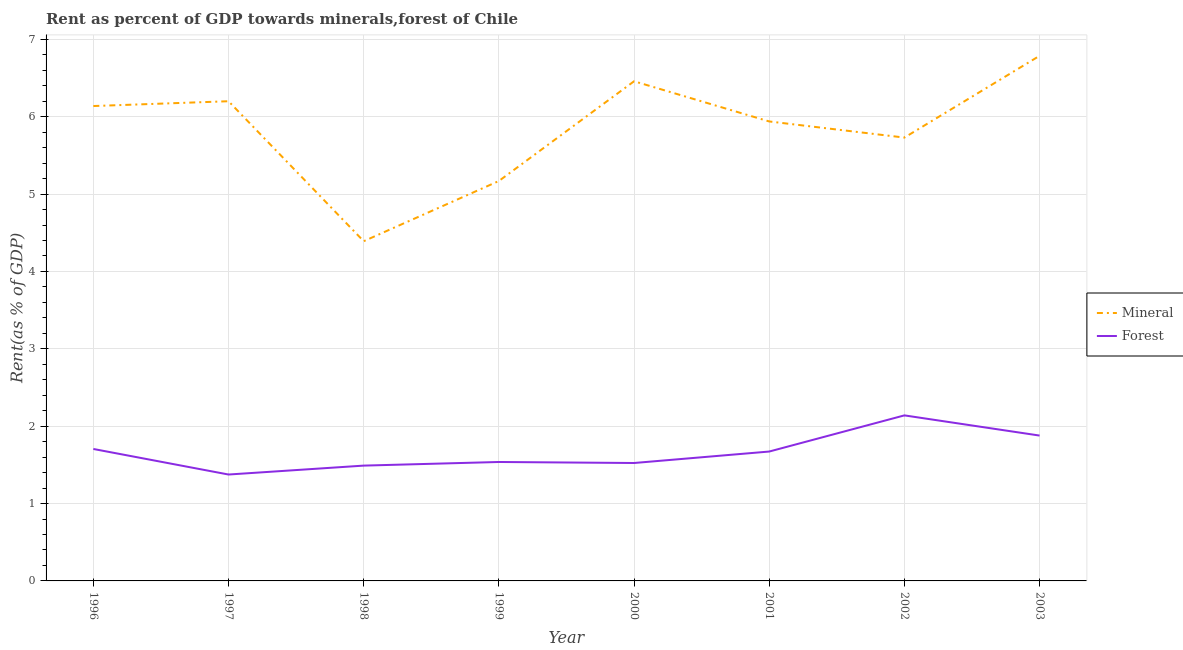Does the line corresponding to mineral rent intersect with the line corresponding to forest rent?
Provide a short and direct response. No. Is the number of lines equal to the number of legend labels?
Provide a succinct answer. Yes. What is the mineral rent in 1999?
Your answer should be compact. 5.17. Across all years, what is the maximum mineral rent?
Provide a succinct answer. 6.79. Across all years, what is the minimum mineral rent?
Keep it short and to the point. 4.39. In which year was the forest rent maximum?
Your answer should be compact. 2002. What is the total mineral rent in the graph?
Make the answer very short. 46.81. What is the difference between the mineral rent in 1999 and that in 2001?
Your answer should be very brief. -0.77. What is the difference between the mineral rent in 1999 and the forest rent in 2002?
Your answer should be very brief. 3.03. What is the average mineral rent per year?
Offer a very short reply. 5.85. In the year 2003, what is the difference between the forest rent and mineral rent?
Your response must be concise. -4.91. In how many years, is the mineral rent greater than 1 %?
Offer a terse response. 8. What is the ratio of the forest rent in 1999 to that in 2000?
Keep it short and to the point. 1.01. Is the mineral rent in 1998 less than that in 2003?
Make the answer very short. Yes. Is the difference between the mineral rent in 2001 and 2003 greater than the difference between the forest rent in 2001 and 2003?
Provide a short and direct response. No. What is the difference between the highest and the second highest forest rent?
Make the answer very short. 0.26. What is the difference between the highest and the lowest mineral rent?
Provide a short and direct response. 2.4. Is the forest rent strictly greater than the mineral rent over the years?
Your answer should be compact. No. Is the forest rent strictly less than the mineral rent over the years?
Offer a very short reply. Yes. Are the values on the major ticks of Y-axis written in scientific E-notation?
Your answer should be compact. No. Does the graph contain grids?
Give a very brief answer. Yes. How many legend labels are there?
Give a very brief answer. 2. What is the title of the graph?
Your answer should be compact. Rent as percent of GDP towards minerals,forest of Chile. What is the label or title of the X-axis?
Your answer should be compact. Year. What is the label or title of the Y-axis?
Offer a terse response. Rent(as % of GDP). What is the Rent(as % of GDP) of Mineral in 1996?
Your answer should be compact. 6.14. What is the Rent(as % of GDP) of Forest in 1996?
Provide a succinct answer. 1.71. What is the Rent(as % of GDP) in Mineral in 1997?
Make the answer very short. 6.2. What is the Rent(as % of GDP) of Forest in 1997?
Your answer should be compact. 1.38. What is the Rent(as % of GDP) of Mineral in 1998?
Ensure brevity in your answer.  4.39. What is the Rent(as % of GDP) of Forest in 1998?
Your answer should be compact. 1.49. What is the Rent(as % of GDP) of Mineral in 1999?
Keep it short and to the point. 5.17. What is the Rent(as % of GDP) of Forest in 1999?
Provide a succinct answer. 1.54. What is the Rent(as % of GDP) of Mineral in 2000?
Provide a succinct answer. 6.46. What is the Rent(as % of GDP) of Forest in 2000?
Your answer should be compact. 1.52. What is the Rent(as % of GDP) in Mineral in 2001?
Offer a terse response. 5.94. What is the Rent(as % of GDP) in Forest in 2001?
Offer a terse response. 1.67. What is the Rent(as % of GDP) in Mineral in 2002?
Give a very brief answer. 5.73. What is the Rent(as % of GDP) of Forest in 2002?
Offer a terse response. 2.14. What is the Rent(as % of GDP) in Mineral in 2003?
Offer a terse response. 6.79. What is the Rent(as % of GDP) in Forest in 2003?
Give a very brief answer. 1.88. Across all years, what is the maximum Rent(as % of GDP) of Mineral?
Your answer should be compact. 6.79. Across all years, what is the maximum Rent(as % of GDP) in Forest?
Keep it short and to the point. 2.14. Across all years, what is the minimum Rent(as % of GDP) of Mineral?
Ensure brevity in your answer.  4.39. Across all years, what is the minimum Rent(as % of GDP) of Forest?
Your answer should be very brief. 1.38. What is the total Rent(as % of GDP) of Mineral in the graph?
Give a very brief answer. 46.81. What is the total Rent(as % of GDP) of Forest in the graph?
Your answer should be very brief. 13.32. What is the difference between the Rent(as % of GDP) of Mineral in 1996 and that in 1997?
Offer a very short reply. -0.06. What is the difference between the Rent(as % of GDP) of Forest in 1996 and that in 1997?
Your answer should be very brief. 0.33. What is the difference between the Rent(as % of GDP) of Mineral in 1996 and that in 1998?
Provide a succinct answer. 1.75. What is the difference between the Rent(as % of GDP) of Forest in 1996 and that in 1998?
Give a very brief answer. 0.22. What is the difference between the Rent(as % of GDP) in Forest in 1996 and that in 1999?
Keep it short and to the point. 0.17. What is the difference between the Rent(as % of GDP) in Mineral in 1996 and that in 2000?
Your response must be concise. -0.32. What is the difference between the Rent(as % of GDP) in Forest in 1996 and that in 2000?
Your answer should be very brief. 0.18. What is the difference between the Rent(as % of GDP) of Mineral in 1996 and that in 2001?
Offer a terse response. 0.2. What is the difference between the Rent(as % of GDP) of Forest in 1996 and that in 2001?
Provide a short and direct response. 0.03. What is the difference between the Rent(as % of GDP) in Mineral in 1996 and that in 2002?
Offer a very short reply. 0.41. What is the difference between the Rent(as % of GDP) in Forest in 1996 and that in 2002?
Keep it short and to the point. -0.43. What is the difference between the Rent(as % of GDP) in Mineral in 1996 and that in 2003?
Provide a succinct answer. -0.65. What is the difference between the Rent(as % of GDP) in Forest in 1996 and that in 2003?
Keep it short and to the point. -0.17. What is the difference between the Rent(as % of GDP) in Mineral in 1997 and that in 1998?
Provide a short and direct response. 1.81. What is the difference between the Rent(as % of GDP) in Forest in 1997 and that in 1998?
Provide a short and direct response. -0.12. What is the difference between the Rent(as % of GDP) of Mineral in 1997 and that in 1999?
Provide a succinct answer. 1.03. What is the difference between the Rent(as % of GDP) of Forest in 1997 and that in 1999?
Keep it short and to the point. -0.16. What is the difference between the Rent(as % of GDP) of Mineral in 1997 and that in 2000?
Keep it short and to the point. -0.26. What is the difference between the Rent(as % of GDP) in Forest in 1997 and that in 2000?
Provide a short and direct response. -0.15. What is the difference between the Rent(as % of GDP) in Mineral in 1997 and that in 2001?
Your answer should be very brief. 0.26. What is the difference between the Rent(as % of GDP) in Forest in 1997 and that in 2001?
Give a very brief answer. -0.3. What is the difference between the Rent(as % of GDP) of Mineral in 1997 and that in 2002?
Your response must be concise. 0.47. What is the difference between the Rent(as % of GDP) of Forest in 1997 and that in 2002?
Provide a succinct answer. -0.76. What is the difference between the Rent(as % of GDP) in Mineral in 1997 and that in 2003?
Your response must be concise. -0.59. What is the difference between the Rent(as % of GDP) of Forest in 1997 and that in 2003?
Offer a terse response. -0.5. What is the difference between the Rent(as % of GDP) in Mineral in 1998 and that in 1999?
Keep it short and to the point. -0.78. What is the difference between the Rent(as % of GDP) in Forest in 1998 and that in 1999?
Keep it short and to the point. -0.05. What is the difference between the Rent(as % of GDP) of Mineral in 1998 and that in 2000?
Your answer should be compact. -2.07. What is the difference between the Rent(as % of GDP) in Forest in 1998 and that in 2000?
Offer a terse response. -0.03. What is the difference between the Rent(as % of GDP) in Mineral in 1998 and that in 2001?
Your answer should be very brief. -1.55. What is the difference between the Rent(as % of GDP) in Forest in 1998 and that in 2001?
Ensure brevity in your answer.  -0.18. What is the difference between the Rent(as % of GDP) of Mineral in 1998 and that in 2002?
Offer a terse response. -1.34. What is the difference between the Rent(as % of GDP) of Forest in 1998 and that in 2002?
Keep it short and to the point. -0.65. What is the difference between the Rent(as % of GDP) in Mineral in 1998 and that in 2003?
Make the answer very short. -2.4. What is the difference between the Rent(as % of GDP) of Forest in 1998 and that in 2003?
Your response must be concise. -0.39. What is the difference between the Rent(as % of GDP) in Mineral in 1999 and that in 2000?
Make the answer very short. -1.29. What is the difference between the Rent(as % of GDP) of Forest in 1999 and that in 2000?
Ensure brevity in your answer.  0.01. What is the difference between the Rent(as % of GDP) of Mineral in 1999 and that in 2001?
Keep it short and to the point. -0.77. What is the difference between the Rent(as % of GDP) of Forest in 1999 and that in 2001?
Provide a short and direct response. -0.14. What is the difference between the Rent(as % of GDP) in Mineral in 1999 and that in 2002?
Make the answer very short. -0.56. What is the difference between the Rent(as % of GDP) of Forest in 1999 and that in 2002?
Your response must be concise. -0.6. What is the difference between the Rent(as % of GDP) in Mineral in 1999 and that in 2003?
Your answer should be very brief. -1.62. What is the difference between the Rent(as % of GDP) of Forest in 1999 and that in 2003?
Provide a short and direct response. -0.34. What is the difference between the Rent(as % of GDP) of Mineral in 2000 and that in 2001?
Provide a short and direct response. 0.52. What is the difference between the Rent(as % of GDP) of Forest in 2000 and that in 2001?
Provide a short and direct response. -0.15. What is the difference between the Rent(as % of GDP) in Mineral in 2000 and that in 2002?
Offer a terse response. 0.73. What is the difference between the Rent(as % of GDP) in Forest in 2000 and that in 2002?
Offer a terse response. -0.62. What is the difference between the Rent(as % of GDP) in Mineral in 2000 and that in 2003?
Provide a short and direct response. -0.33. What is the difference between the Rent(as % of GDP) of Forest in 2000 and that in 2003?
Your answer should be very brief. -0.35. What is the difference between the Rent(as % of GDP) of Mineral in 2001 and that in 2002?
Your response must be concise. 0.21. What is the difference between the Rent(as % of GDP) in Forest in 2001 and that in 2002?
Make the answer very short. -0.47. What is the difference between the Rent(as % of GDP) of Mineral in 2001 and that in 2003?
Offer a very short reply. -0.85. What is the difference between the Rent(as % of GDP) in Forest in 2001 and that in 2003?
Your answer should be compact. -0.21. What is the difference between the Rent(as % of GDP) of Mineral in 2002 and that in 2003?
Give a very brief answer. -1.06. What is the difference between the Rent(as % of GDP) in Forest in 2002 and that in 2003?
Make the answer very short. 0.26. What is the difference between the Rent(as % of GDP) in Mineral in 1996 and the Rent(as % of GDP) in Forest in 1997?
Offer a very short reply. 4.76. What is the difference between the Rent(as % of GDP) of Mineral in 1996 and the Rent(as % of GDP) of Forest in 1998?
Keep it short and to the point. 4.65. What is the difference between the Rent(as % of GDP) of Mineral in 1996 and the Rent(as % of GDP) of Forest in 1999?
Provide a short and direct response. 4.6. What is the difference between the Rent(as % of GDP) in Mineral in 1996 and the Rent(as % of GDP) in Forest in 2000?
Offer a terse response. 4.61. What is the difference between the Rent(as % of GDP) in Mineral in 1996 and the Rent(as % of GDP) in Forest in 2001?
Give a very brief answer. 4.47. What is the difference between the Rent(as % of GDP) in Mineral in 1996 and the Rent(as % of GDP) in Forest in 2002?
Your answer should be compact. 4. What is the difference between the Rent(as % of GDP) in Mineral in 1996 and the Rent(as % of GDP) in Forest in 2003?
Your answer should be compact. 4.26. What is the difference between the Rent(as % of GDP) in Mineral in 1997 and the Rent(as % of GDP) in Forest in 1998?
Ensure brevity in your answer.  4.71. What is the difference between the Rent(as % of GDP) of Mineral in 1997 and the Rent(as % of GDP) of Forest in 1999?
Keep it short and to the point. 4.66. What is the difference between the Rent(as % of GDP) in Mineral in 1997 and the Rent(as % of GDP) in Forest in 2000?
Your answer should be compact. 4.68. What is the difference between the Rent(as % of GDP) in Mineral in 1997 and the Rent(as % of GDP) in Forest in 2001?
Make the answer very short. 4.53. What is the difference between the Rent(as % of GDP) of Mineral in 1997 and the Rent(as % of GDP) of Forest in 2002?
Offer a terse response. 4.06. What is the difference between the Rent(as % of GDP) of Mineral in 1997 and the Rent(as % of GDP) of Forest in 2003?
Your response must be concise. 4.32. What is the difference between the Rent(as % of GDP) in Mineral in 1998 and the Rent(as % of GDP) in Forest in 1999?
Make the answer very short. 2.85. What is the difference between the Rent(as % of GDP) of Mineral in 1998 and the Rent(as % of GDP) of Forest in 2000?
Offer a terse response. 2.87. What is the difference between the Rent(as % of GDP) in Mineral in 1998 and the Rent(as % of GDP) in Forest in 2001?
Provide a short and direct response. 2.72. What is the difference between the Rent(as % of GDP) of Mineral in 1998 and the Rent(as % of GDP) of Forest in 2002?
Offer a terse response. 2.25. What is the difference between the Rent(as % of GDP) in Mineral in 1998 and the Rent(as % of GDP) in Forest in 2003?
Make the answer very short. 2.51. What is the difference between the Rent(as % of GDP) of Mineral in 1999 and the Rent(as % of GDP) of Forest in 2000?
Make the answer very short. 3.65. What is the difference between the Rent(as % of GDP) of Mineral in 1999 and the Rent(as % of GDP) of Forest in 2001?
Your answer should be very brief. 3.5. What is the difference between the Rent(as % of GDP) in Mineral in 1999 and the Rent(as % of GDP) in Forest in 2002?
Provide a succinct answer. 3.03. What is the difference between the Rent(as % of GDP) in Mineral in 1999 and the Rent(as % of GDP) in Forest in 2003?
Your answer should be very brief. 3.29. What is the difference between the Rent(as % of GDP) of Mineral in 2000 and the Rent(as % of GDP) of Forest in 2001?
Offer a terse response. 4.79. What is the difference between the Rent(as % of GDP) in Mineral in 2000 and the Rent(as % of GDP) in Forest in 2002?
Provide a short and direct response. 4.32. What is the difference between the Rent(as % of GDP) of Mineral in 2000 and the Rent(as % of GDP) of Forest in 2003?
Your answer should be compact. 4.58. What is the difference between the Rent(as % of GDP) of Mineral in 2001 and the Rent(as % of GDP) of Forest in 2002?
Give a very brief answer. 3.8. What is the difference between the Rent(as % of GDP) in Mineral in 2001 and the Rent(as % of GDP) in Forest in 2003?
Provide a short and direct response. 4.06. What is the difference between the Rent(as % of GDP) in Mineral in 2002 and the Rent(as % of GDP) in Forest in 2003?
Provide a succinct answer. 3.85. What is the average Rent(as % of GDP) of Mineral per year?
Offer a terse response. 5.85. What is the average Rent(as % of GDP) in Forest per year?
Provide a succinct answer. 1.67. In the year 1996, what is the difference between the Rent(as % of GDP) in Mineral and Rent(as % of GDP) in Forest?
Give a very brief answer. 4.43. In the year 1997, what is the difference between the Rent(as % of GDP) of Mineral and Rent(as % of GDP) of Forest?
Your answer should be compact. 4.83. In the year 1998, what is the difference between the Rent(as % of GDP) in Mineral and Rent(as % of GDP) in Forest?
Ensure brevity in your answer.  2.9. In the year 1999, what is the difference between the Rent(as % of GDP) of Mineral and Rent(as % of GDP) of Forest?
Your answer should be very brief. 3.63. In the year 2000, what is the difference between the Rent(as % of GDP) in Mineral and Rent(as % of GDP) in Forest?
Your answer should be compact. 4.93. In the year 2001, what is the difference between the Rent(as % of GDP) of Mineral and Rent(as % of GDP) of Forest?
Offer a very short reply. 4.27. In the year 2002, what is the difference between the Rent(as % of GDP) in Mineral and Rent(as % of GDP) in Forest?
Ensure brevity in your answer.  3.59. In the year 2003, what is the difference between the Rent(as % of GDP) in Mineral and Rent(as % of GDP) in Forest?
Provide a short and direct response. 4.91. What is the ratio of the Rent(as % of GDP) in Forest in 1996 to that in 1997?
Make the answer very short. 1.24. What is the ratio of the Rent(as % of GDP) of Mineral in 1996 to that in 1998?
Offer a very short reply. 1.4. What is the ratio of the Rent(as % of GDP) in Forest in 1996 to that in 1998?
Your response must be concise. 1.14. What is the ratio of the Rent(as % of GDP) in Mineral in 1996 to that in 1999?
Offer a very short reply. 1.19. What is the ratio of the Rent(as % of GDP) in Forest in 1996 to that in 1999?
Your answer should be compact. 1.11. What is the ratio of the Rent(as % of GDP) of Mineral in 1996 to that in 2000?
Provide a short and direct response. 0.95. What is the ratio of the Rent(as % of GDP) in Forest in 1996 to that in 2000?
Make the answer very short. 1.12. What is the ratio of the Rent(as % of GDP) of Mineral in 1996 to that in 2001?
Your answer should be very brief. 1.03. What is the ratio of the Rent(as % of GDP) in Forest in 1996 to that in 2001?
Make the answer very short. 1.02. What is the ratio of the Rent(as % of GDP) of Mineral in 1996 to that in 2002?
Your answer should be compact. 1.07. What is the ratio of the Rent(as % of GDP) of Forest in 1996 to that in 2002?
Provide a succinct answer. 0.8. What is the ratio of the Rent(as % of GDP) in Mineral in 1996 to that in 2003?
Your response must be concise. 0.9. What is the ratio of the Rent(as % of GDP) in Forest in 1996 to that in 2003?
Offer a terse response. 0.91. What is the ratio of the Rent(as % of GDP) in Mineral in 1997 to that in 1998?
Provide a succinct answer. 1.41. What is the ratio of the Rent(as % of GDP) in Forest in 1997 to that in 1998?
Provide a succinct answer. 0.92. What is the ratio of the Rent(as % of GDP) of Mineral in 1997 to that in 1999?
Make the answer very short. 1.2. What is the ratio of the Rent(as % of GDP) in Forest in 1997 to that in 1999?
Give a very brief answer. 0.89. What is the ratio of the Rent(as % of GDP) in Mineral in 1997 to that in 2000?
Keep it short and to the point. 0.96. What is the ratio of the Rent(as % of GDP) of Forest in 1997 to that in 2000?
Give a very brief answer. 0.9. What is the ratio of the Rent(as % of GDP) of Mineral in 1997 to that in 2001?
Provide a short and direct response. 1.04. What is the ratio of the Rent(as % of GDP) of Forest in 1997 to that in 2001?
Keep it short and to the point. 0.82. What is the ratio of the Rent(as % of GDP) in Mineral in 1997 to that in 2002?
Provide a short and direct response. 1.08. What is the ratio of the Rent(as % of GDP) of Forest in 1997 to that in 2002?
Your answer should be very brief. 0.64. What is the ratio of the Rent(as % of GDP) in Mineral in 1997 to that in 2003?
Your answer should be compact. 0.91. What is the ratio of the Rent(as % of GDP) in Forest in 1997 to that in 2003?
Provide a short and direct response. 0.73. What is the ratio of the Rent(as % of GDP) in Mineral in 1998 to that in 1999?
Provide a short and direct response. 0.85. What is the ratio of the Rent(as % of GDP) in Forest in 1998 to that in 1999?
Provide a short and direct response. 0.97. What is the ratio of the Rent(as % of GDP) in Mineral in 1998 to that in 2000?
Make the answer very short. 0.68. What is the ratio of the Rent(as % of GDP) in Forest in 1998 to that in 2000?
Keep it short and to the point. 0.98. What is the ratio of the Rent(as % of GDP) of Mineral in 1998 to that in 2001?
Provide a short and direct response. 0.74. What is the ratio of the Rent(as % of GDP) of Forest in 1998 to that in 2001?
Ensure brevity in your answer.  0.89. What is the ratio of the Rent(as % of GDP) of Mineral in 1998 to that in 2002?
Ensure brevity in your answer.  0.77. What is the ratio of the Rent(as % of GDP) in Forest in 1998 to that in 2002?
Make the answer very short. 0.7. What is the ratio of the Rent(as % of GDP) in Mineral in 1998 to that in 2003?
Give a very brief answer. 0.65. What is the ratio of the Rent(as % of GDP) of Forest in 1998 to that in 2003?
Provide a short and direct response. 0.79. What is the ratio of the Rent(as % of GDP) of Mineral in 1999 to that in 2000?
Your answer should be very brief. 0.8. What is the ratio of the Rent(as % of GDP) of Forest in 1999 to that in 2000?
Make the answer very short. 1.01. What is the ratio of the Rent(as % of GDP) in Mineral in 1999 to that in 2001?
Ensure brevity in your answer.  0.87. What is the ratio of the Rent(as % of GDP) in Forest in 1999 to that in 2001?
Your answer should be very brief. 0.92. What is the ratio of the Rent(as % of GDP) of Mineral in 1999 to that in 2002?
Your answer should be compact. 0.9. What is the ratio of the Rent(as % of GDP) in Forest in 1999 to that in 2002?
Give a very brief answer. 0.72. What is the ratio of the Rent(as % of GDP) in Mineral in 1999 to that in 2003?
Keep it short and to the point. 0.76. What is the ratio of the Rent(as % of GDP) of Forest in 1999 to that in 2003?
Offer a very short reply. 0.82. What is the ratio of the Rent(as % of GDP) of Mineral in 2000 to that in 2001?
Provide a short and direct response. 1.09. What is the ratio of the Rent(as % of GDP) in Forest in 2000 to that in 2001?
Make the answer very short. 0.91. What is the ratio of the Rent(as % of GDP) of Mineral in 2000 to that in 2002?
Provide a short and direct response. 1.13. What is the ratio of the Rent(as % of GDP) in Forest in 2000 to that in 2002?
Make the answer very short. 0.71. What is the ratio of the Rent(as % of GDP) of Mineral in 2000 to that in 2003?
Keep it short and to the point. 0.95. What is the ratio of the Rent(as % of GDP) of Forest in 2000 to that in 2003?
Provide a succinct answer. 0.81. What is the ratio of the Rent(as % of GDP) in Mineral in 2001 to that in 2002?
Make the answer very short. 1.04. What is the ratio of the Rent(as % of GDP) of Forest in 2001 to that in 2002?
Give a very brief answer. 0.78. What is the ratio of the Rent(as % of GDP) in Forest in 2001 to that in 2003?
Keep it short and to the point. 0.89. What is the ratio of the Rent(as % of GDP) of Mineral in 2002 to that in 2003?
Offer a very short reply. 0.84. What is the ratio of the Rent(as % of GDP) in Forest in 2002 to that in 2003?
Offer a terse response. 1.14. What is the difference between the highest and the second highest Rent(as % of GDP) of Mineral?
Give a very brief answer. 0.33. What is the difference between the highest and the second highest Rent(as % of GDP) of Forest?
Your answer should be compact. 0.26. What is the difference between the highest and the lowest Rent(as % of GDP) in Mineral?
Give a very brief answer. 2.4. What is the difference between the highest and the lowest Rent(as % of GDP) of Forest?
Your response must be concise. 0.76. 